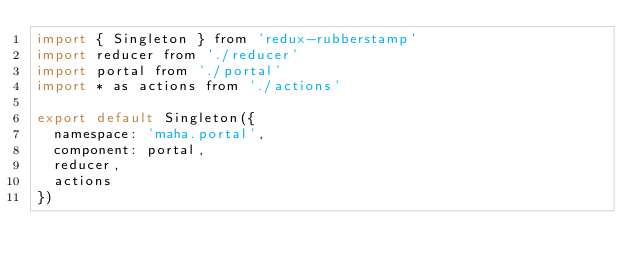<code> <loc_0><loc_0><loc_500><loc_500><_JavaScript_>import { Singleton } from 'redux-rubberstamp'
import reducer from './reducer'
import portal from './portal'
import * as actions from './actions'

export default Singleton({
  namespace: 'maha.portal',
  component: portal,
  reducer,
  actions
})
</code> 